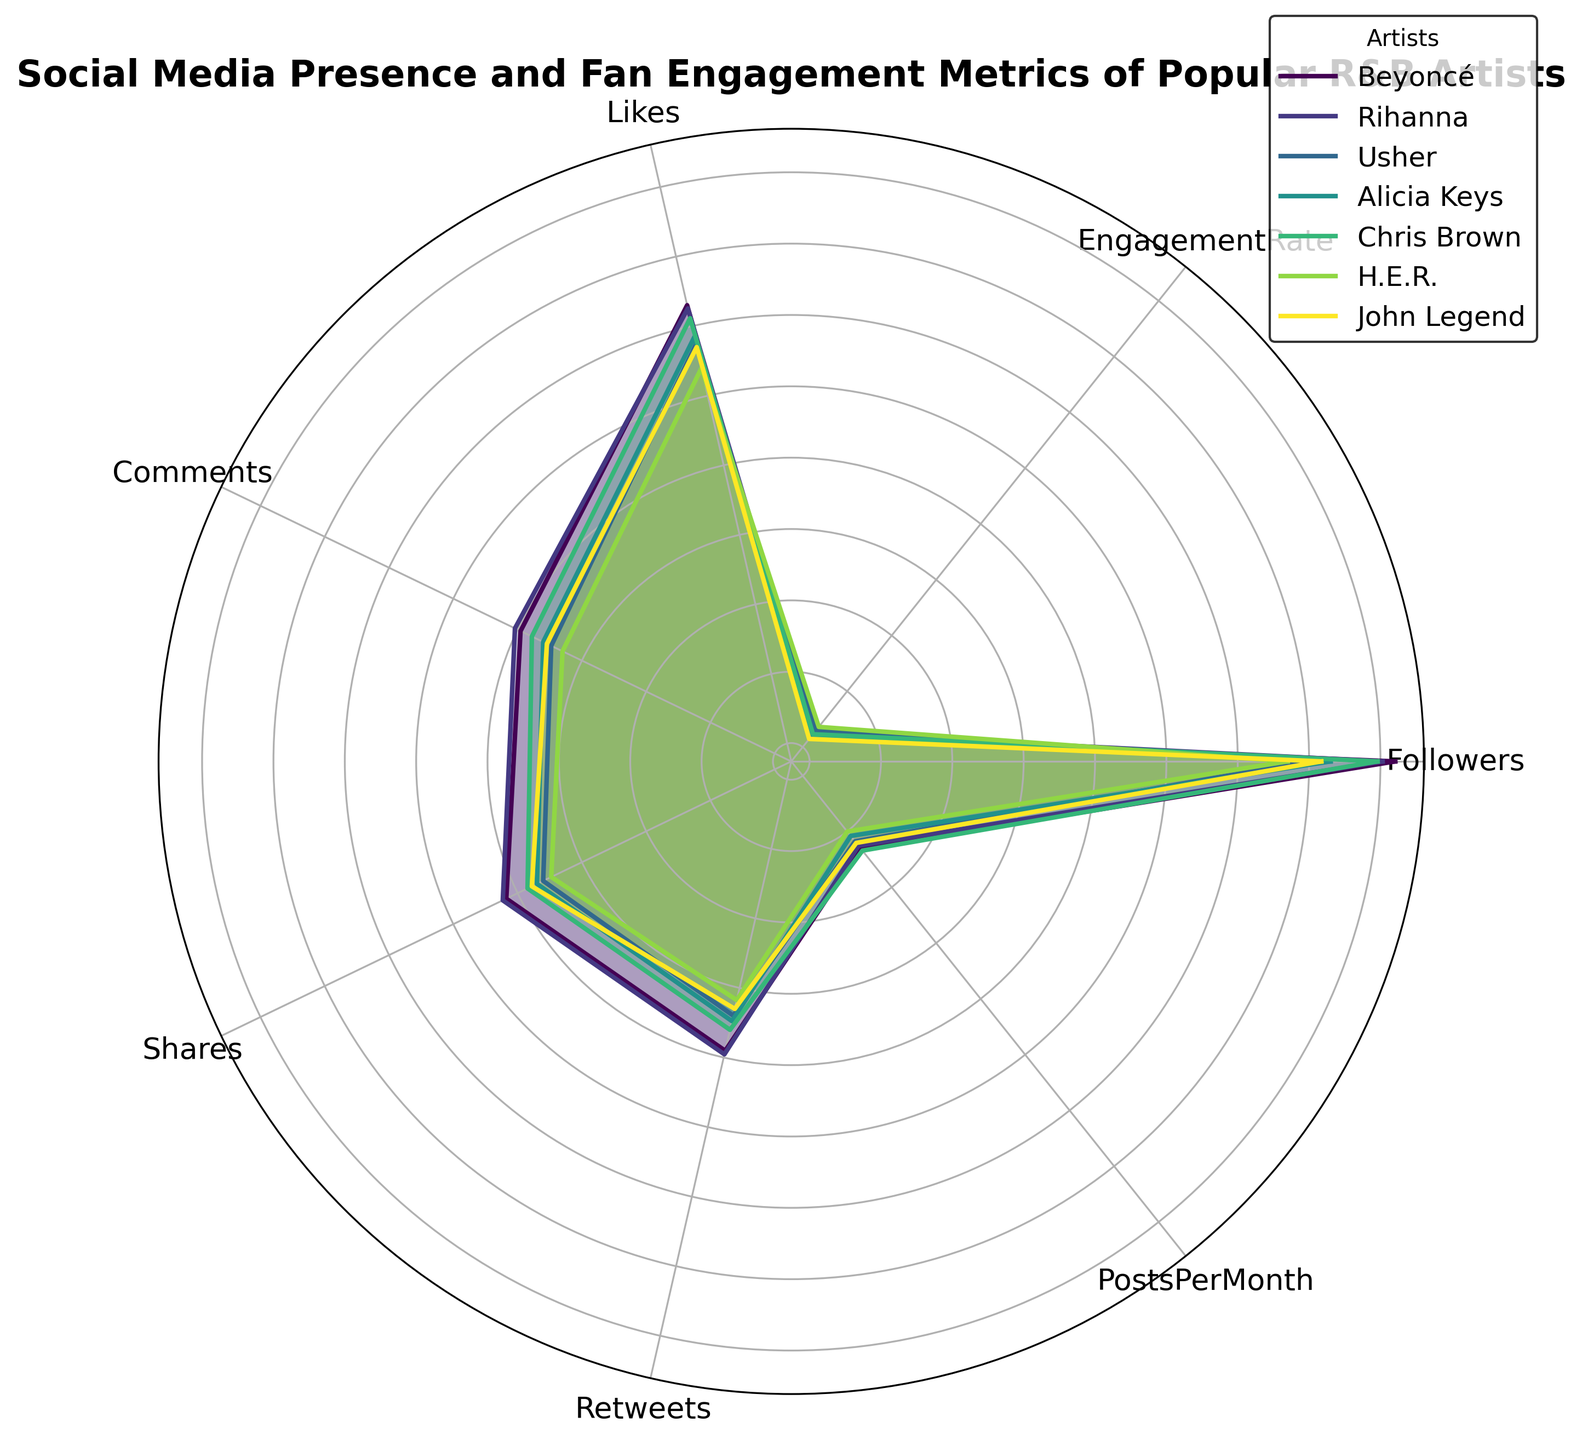Which artist has the highest engagement rate? By looking at the radar chart, you can identify the artist with the highest engagement rate by comparing the value on the "EngagementRate" axis. H.E.R. has the highest engagement rate with 2.3.
Answer: H.E.R Which artist posts the most per month? You can find the artist with the highest "PostsPerMonth" value by comparing the lengths of the radials on the corresponding axis. Chris Brown posts 22 times per month.
Answer: Chris Brown How does Beyoncé's comment count compare to Rihanna's? Look at the "Comments" axis and compare the positions of Beyoncé and Rihanna. Beyoncé has 9,000 comments, while Rihanna has 11,000 comments. Rihanna has more comments than Beyoncé.
Answer: Rihanna has more comments What is the average number of followers for John Legend and Alicia Keys? Calculate the average by adding the number of followers for John Legend (14.8 million) and Alicia Keys (20 million), then divide by 2: (14800000 + 20000000) / 2 = 17.4 million.
Answer: 17.4 million Which artist has the least number of shares? By comparing the values on the "Shares" axis for all artists, H.E.R. has the least number of shares with 3,000.
Answer: H.E.R How do Chris Brown's and Usher's engagement rates compare? Compare their positions on the "EngagementRate" axis. Chris Brown has an engagement rate of 1.7, while Usher has an engagement rate of 2.0. Usher has a higher engagement rate.
Answer: Usher has a higher engagement rate Rank the artists by post frequency, starting with the most frequent poster. Compare the length of radials on the "PostsPerMonth" axis for all artists. The order from most to least frequent posters is: Chris Brown, Beyoncé, Rihanna, John Legend, Usher, Alicia Keys, H.E.R.
Answer: Chris Brown > Beyoncé > Rihanna > John Legend > Usher > Alicia Keys > H.E.R What is the total number of likes for Beyoncé and H.E.R.? Add the number of likes for both artists: 2,000,000 (Beyoncé) + 250,000 (H.E.R.) = 2,250,000 likes.
Answer: 2,250,000 likes Which artist has the lowest engagement rate? Compare the values on the "EngagementRate" axis, and John Legend has the lowest engagement rate with 1.4.
Answer: John Legend 